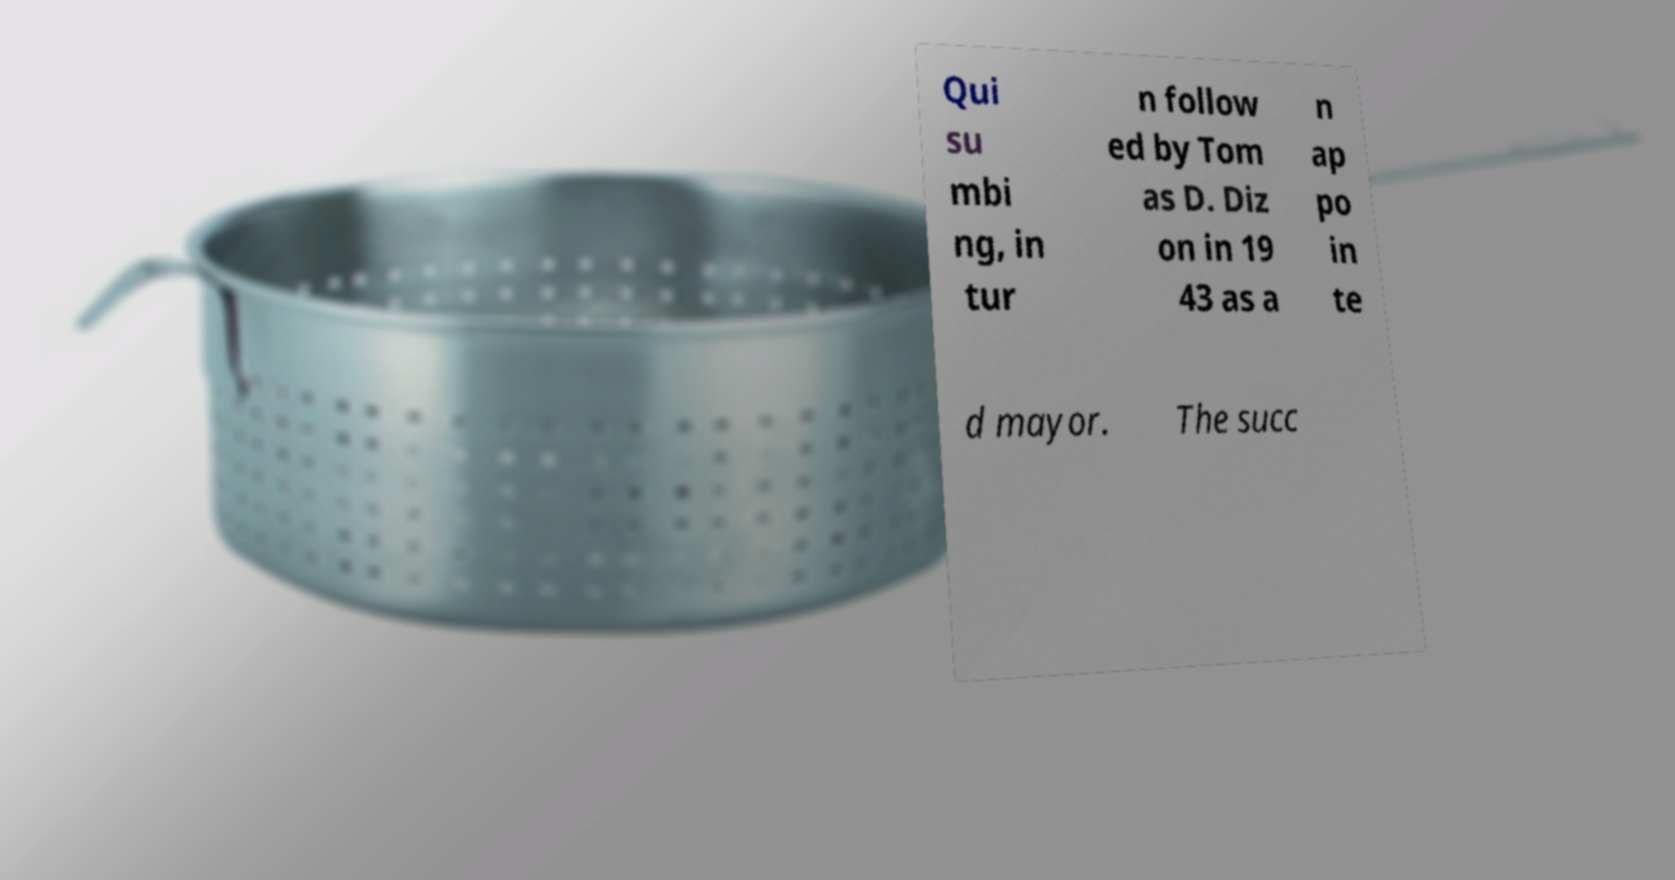Please identify and transcribe the text found in this image. Qui su mbi ng, in tur n follow ed by Tom as D. Diz on in 19 43 as a n ap po in te d mayor. The succ 